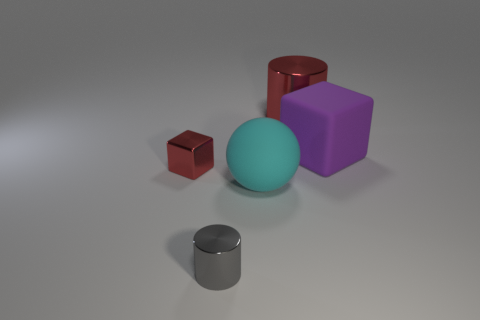Add 4 big purple blocks. How many objects exist? 9 Subtract all spheres. How many objects are left? 4 Add 4 tiny brown rubber balls. How many tiny brown rubber balls exist? 4 Subtract 1 red blocks. How many objects are left? 4 Subtract all purple matte things. Subtract all metal things. How many objects are left? 1 Add 5 rubber balls. How many rubber balls are left? 6 